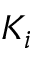<formula> <loc_0><loc_0><loc_500><loc_500>K _ { i }</formula> 